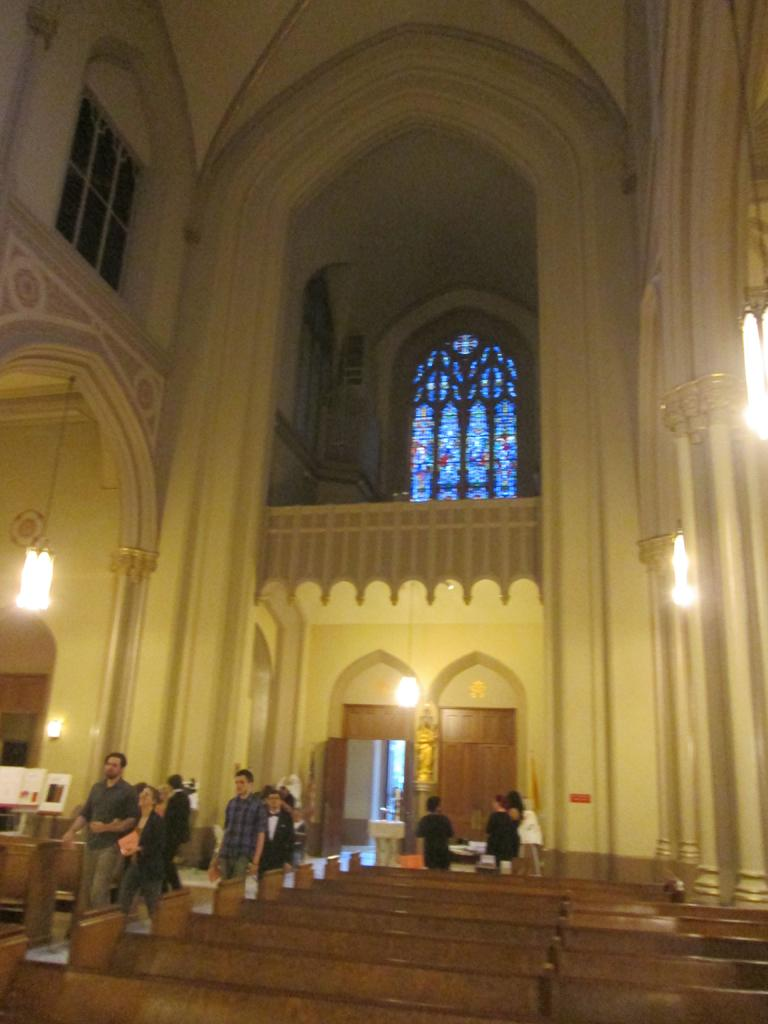What type of seating is visible in the image? There are benches in the image. What are the people in the image doing? A: The people are on the floor in the image. What can be seen in the background of the image? There are boards, lights, doors, windows, and a statue visible in the background of the image. Are there any other objects visible in the background of the image? Yes, there are other objects visible in the background of the image. What type of science experiment is being conducted by the people on the floor in the image? There is no indication of a science experiment being conducted in the image. Can you see any smoke coming from the objects in the background of the image? There is no smoke visible in the image. Are the people in the image driving any vehicles? There is no indication of driving or vehicles in the image. 